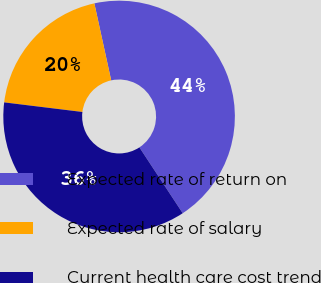Convert chart to OTSL. <chart><loc_0><loc_0><loc_500><loc_500><pie_chart><fcel>Expected rate of return on<fcel>Expected rate of salary<fcel>Current health care cost trend<nl><fcel>44.17%<fcel>19.63%<fcel>36.2%<nl></chart> 